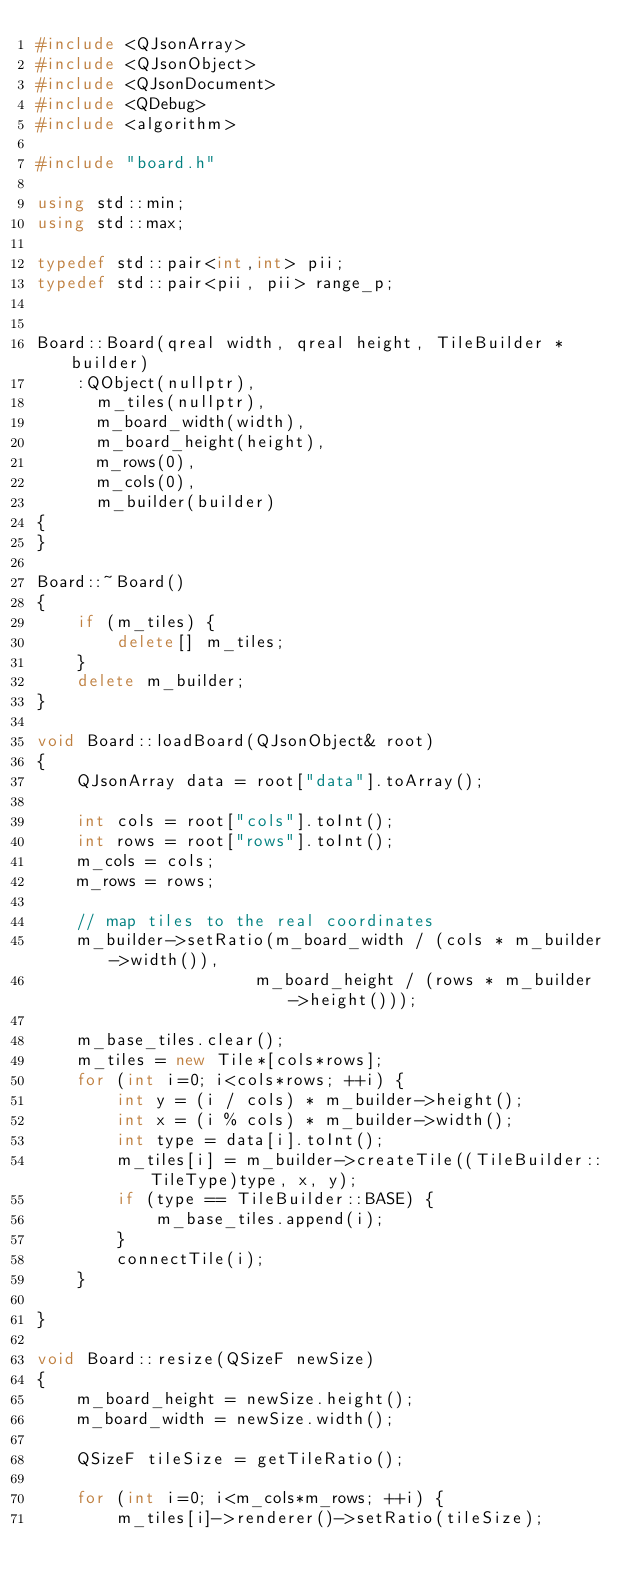Convert code to text. <code><loc_0><loc_0><loc_500><loc_500><_C++_>#include <QJsonArray>
#include <QJsonObject>
#include <QJsonDocument>
#include <QDebug>
#include <algorithm>

#include "board.h"

using std::min;
using std::max;

typedef std::pair<int,int> pii;
typedef std::pair<pii, pii> range_p;


Board::Board(qreal width, qreal height, TileBuilder *builder)
    :QObject(nullptr),
      m_tiles(nullptr),
      m_board_width(width),
      m_board_height(height),
      m_rows(0),
      m_cols(0),
      m_builder(builder)
{
}

Board::~Board()
{
    if (m_tiles) {
        delete[] m_tiles;
    }
    delete m_builder;
}

void Board::loadBoard(QJsonObject& root)
{
    QJsonArray data = root["data"].toArray();

    int cols = root["cols"].toInt();
    int rows = root["rows"].toInt();
    m_cols = cols;
    m_rows = rows;

    // map tiles to the real coordinates
    m_builder->setRatio(m_board_width / (cols * m_builder->width()),
                      m_board_height / (rows * m_builder->height()));

    m_base_tiles.clear();
    m_tiles = new Tile*[cols*rows];
    for (int i=0; i<cols*rows; ++i) {
        int y = (i / cols) * m_builder->height();
        int x = (i % cols) * m_builder->width();
        int type = data[i].toInt();
        m_tiles[i] = m_builder->createTile((TileBuilder::TileType)type, x, y);
        if (type == TileBuilder::BASE) {
            m_base_tiles.append(i);
        }
        connectTile(i);
    }

}

void Board::resize(QSizeF newSize)
{
    m_board_height = newSize.height();
    m_board_width = newSize.width();

    QSizeF tileSize = getTileRatio();

    for (int i=0; i<m_cols*m_rows; ++i) {
        m_tiles[i]->renderer()->setRatio(tileSize);</code> 